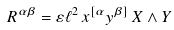<formula> <loc_0><loc_0><loc_500><loc_500>R ^ { { \alpha } { \beta } } = \varepsilon \ell ^ { 2 } \, x ^ { [ \alpha } y ^ { \beta ] } \, X \wedge Y</formula> 